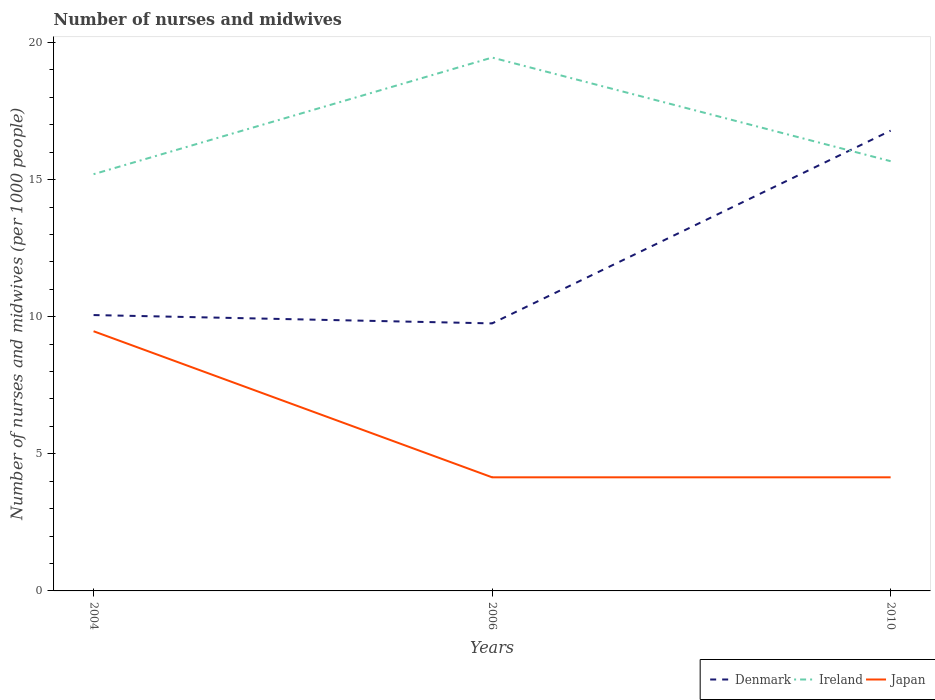Does the line corresponding to Denmark intersect with the line corresponding to Ireland?
Provide a short and direct response. Yes. Is the number of lines equal to the number of legend labels?
Ensure brevity in your answer.  Yes. Across all years, what is the maximum number of nurses and midwives in in Ireland?
Offer a very short reply. 15.2. What is the total number of nurses and midwives in in Ireland in the graph?
Your answer should be compact. 3.78. What is the difference between the highest and the second highest number of nurses and midwives in in Japan?
Your answer should be compact. 5.33. How many lines are there?
Your response must be concise. 3. How many years are there in the graph?
Give a very brief answer. 3. What is the difference between two consecutive major ticks on the Y-axis?
Make the answer very short. 5. Are the values on the major ticks of Y-axis written in scientific E-notation?
Keep it short and to the point. No. How many legend labels are there?
Provide a succinct answer. 3. What is the title of the graph?
Offer a very short reply. Number of nurses and midwives. What is the label or title of the Y-axis?
Provide a short and direct response. Number of nurses and midwives (per 1000 people). What is the Number of nurses and midwives (per 1000 people) of Denmark in 2004?
Provide a short and direct response. 10.06. What is the Number of nurses and midwives (per 1000 people) in Ireland in 2004?
Your answer should be compact. 15.2. What is the Number of nurses and midwives (per 1000 people) in Japan in 2004?
Keep it short and to the point. 9.47. What is the Number of nurses and midwives (per 1000 people) of Denmark in 2006?
Give a very brief answer. 9.76. What is the Number of nurses and midwives (per 1000 people) in Ireland in 2006?
Your answer should be compact. 19.45. What is the Number of nurses and midwives (per 1000 people) of Japan in 2006?
Provide a short and direct response. 4.14. What is the Number of nurses and midwives (per 1000 people) in Denmark in 2010?
Give a very brief answer. 16.79. What is the Number of nurses and midwives (per 1000 people) of Ireland in 2010?
Your answer should be compact. 15.67. What is the Number of nurses and midwives (per 1000 people) in Japan in 2010?
Make the answer very short. 4.14. Across all years, what is the maximum Number of nurses and midwives (per 1000 people) of Denmark?
Your answer should be compact. 16.79. Across all years, what is the maximum Number of nurses and midwives (per 1000 people) in Ireland?
Provide a short and direct response. 19.45. Across all years, what is the maximum Number of nurses and midwives (per 1000 people) of Japan?
Your answer should be compact. 9.47. Across all years, what is the minimum Number of nurses and midwives (per 1000 people) of Denmark?
Your answer should be very brief. 9.76. Across all years, what is the minimum Number of nurses and midwives (per 1000 people) of Ireland?
Your response must be concise. 15.2. Across all years, what is the minimum Number of nurses and midwives (per 1000 people) of Japan?
Your answer should be very brief. 4.14. What is the total Number of nurses and midwives (per 1000 people) in Denmark in the graph?
Offer a terse response. 36.6. What is the total Number of nurses and midwives (per 1000 people) in Ireland in the graph?
Your response must be concise. 50.32. What is the total Number of nurses and midwives (per 1000 people) in Japan in the graph?
Your response must be concise. 17.76. What is the difference between the Number of nurses and midwives (per 1000 people) of Denmark in 2004 and that in 2006?
Provide a succinct answer. 0.3. What is the difference between the Number of nurses and midwives (per 1000 people) in Ireland in 2004 and that in 2006?
Offer a terse response. -4.25. What is the difference between the Number of nurses and midwives (per 1000 people) of Japan in 2004 and that in 2006?
Your response must be concise. 5.33. What is the difference between the Number of nurses and midwives (per 1000 people) in Denmark in 2004 and that in 2010?
Your response must be concise. -6.72. What is the difference between the Number of nurses and midwives (per 1000 people) of Ireland in 2004 and that in 2010?
Ensure brevity in your answer.  -0.47. What is the difference between the Number of nurses and midwives (per 1000 people) of Japan in 2004 and that in 2010?
Offer a terse response. 5.33. What is the difference between the Number of nurses and midwives (per 1000 people) in Denmark in 2006 and that in 2010?
Offer a very short reply. -7.03. What is the difference between the Number of nurses and midwives (per 1000 people) in Ireland in 2006 and that in 2010?
Offer a terse response. 3.78. What is the difference between the Number of nurses and midwives (per 1000 people) in Japan in 2006 and that in 2010?
Your answer should be compact. 0. What is the difference between the Number of nurses and midwives (per 1000 people) in Denmark in 2004 and the Number of nurses and midwives (per 1000 people) in Ireland in 2006?
Your answer should be compact. -9.39. What is the difference between the Number of nurses and midwives (per 1000 people) in Denmark in 2004 and the Number of nurses and midwives (per 1000 people) in Japan in 2006?
Ensure brevity in your answer.  5.92. What is the difference between the Number of nurses and midwives (per 1000 people) of Ireland in 2004 and the Number of nurses and midwives (per 1000 people) of Japan in 2006?
Make the answer very short. 11.05. What is the difference between the Number of nurses and midwives (per 1000 people) of Denmark in 2004 and the Number of nurses and midwives (per 1000 people) of Ireland in 2010?
Provide a succinct answer. -5.61. What is the difference between the Number of nurses and midwives (per 1000 people) in Denmark in 2004 and the Number of nurses and midwives (per 1000 people) in Japan in 2010?
Offer a terse response. 5.92. What is the difference between the Number of nurses and midwives (per 1000 people) in Ireland in 2004 and the Number of nurses and midwives (per 1000 people) in Japan in 2010?
Ensure brevity in your answer.  11.05. What is the difference between the Number of nurses and midwives (per 1000 people) in Denmark in 2006 and the Number of nurses and midwives (per 1000 people) in Ireland in 2010?
Give a very brief answer. -5.92. What is the difference between the Number of nurses and midwives (per 1000 people) in Denmark in 2006 and the Number of nurses and midwives (per 1000 people) in Japan in 2010?
Offer a terse response. 5.61. What is the difference between the Number of nurses and midwives (per 1000 people) of Ireland in 2006 and the Number of nurses and midwives (per 1000 people) of Japan in 2010?
Your answer should be compact. 15.31. What is the average Number of nurses and midwives (per 1000 people) of Denmark per year?
Offer a terse response. 12.2. What is the average Number of nurses and midwives (per 1000 people) in Ireland per year?
Offer a terse response. 16.77. What is the average Number of nurses and midwives (per 1000 people) of Japan per year?
Provide a succinct answer. 5.92. In the year 2004, what is the difference between the Number of nurses and midwives (per 1000 people) in Denmark and Number of nurses and midwives (per 1000 people) in Ireland?
Ensure brevity in your answer.  -5.14. In the year 2004, what is the difference between the Number of nurses and midwives (per 1000 people) in Denmark and Number of nurses and midwives (per 1000 people) in Japan?
Give a very brief answer. 0.59. In the year 2004, what is the difference between the Number of nurses and midwives (per 1000 people) in Ireland and Number of nurses and midwives (per 1000 people) in Japan?
Offer a very short reply. 5.73. In the year 2006, what is the difference between the Number of nurses and midwives (per 1000 people) of Denmark and Number of nurses and midwives (per 1000 people) of Ireland?
Make the answer very short. -9.69. In the year 2006, what is the difference between the Number of nurses and midwives (per 1000 people) of Denmark and Number of nurses and midwives (per 1000 people) of Japan?
Your answer should be very brief. 5.61. In the year 2006, what is the difference between the Number of nurses and midwives (per 1000 people) in Ireland and Number of nurses and midwives (per 1000 people) in Japan?
Keep it short and to the point. 15.31. In the year 2010, what is the difference between the Number of nurses and midwives (per 1000 people) in Denmark and Number of nurses and midwives (per 1000 people) in Ireland?
Your response must be concise. 1.11. In the year 2010, what is the difference between the Number of nurses and midwives (per 1000 people) of Denmark and Number of nurses and midwives (per 1000 people) of Japan?
Your answer should be compact. 12.64. In the year 2010, what is the difference between the Number of nurses and midwives (per 1000 people) in Ireland and Number of nurses and midwives (per 1000 people) in Japan?
Ensure brevity in your answer.  11.53. What is the ratio of the Number of nurses and midwives (per 1000 people) in Denmark in 2004 to that in 2006?
Ensure brevity in your answer.  1.03. What is the ratio of the Number of nurses and midwives (per 1000 people) of Ireland in 2004 to that in 2006?
Provide a short and direct response. 0.78. What is the ratio of the Number of nurses and midwives (per 1000 people) of Japan in 2004 to that in 2006?
Provide a short and direct response. 2.29. What is the ratio of the Number of nurses and midwives (per 1000 people) of Denmark in 2004 to that in 2010?
Give a very brief answer. 0.6. What is the ratio of the Number of nurses and midwives (per 1000 people) in Ireland in 2004 to that in 2010?
Provide a succinct answer. 0.97. What is the ratio of the Number of nurses and midwives (per 1000 people) of Japan in 2004 to that in 2010?
Your answer should be very brief. 2.29. What is the ratio of the Number of nurses and midwives (per 1000 people) in Denmark in 2006 to that in 2010?
Make the answer very short. 0.58. What is the ratio of the Number of nurses and midwives (per 1000 people) in Ireland in 2006 to that in 2010?
Your answer should be very brief. 1.24. What is the ratio of the Number of nurses and midwives (per 1000 people) of Japan in 2006 to that in 2010?
Your response must be concise. 1. What is the difference between the highest and the second highest Number of nurses and midwives (per 1000 people) in Denmark?
Offer a terse response. 6.72. What is the difference between the highest and the second highest Number of nurses and midwives (per 1000 people) of Ireland?
Provide a succinct answer. 3.78. What is the difference between the highest and the second highest Number of nurses and midwives (per 1000 people) of Japan?
Your answer should be compact. 5.33. What is the difference between the highest and the lowest Number of nurses and midwives (per 1000 people) in Denmark?
Your answer should be very brief. 7.03. What is the difference between the highest and the lowest Number of nurses and midwives (per 1000 people) in Ireland?
Make the answer very short. 4.25. What is the difference between the highest and the lowest Number of nurses and midwives (per 1000 people) of Japan?
Offer a terse response. 5.33. 